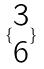Convert formula to latex. <formula><loc_0><loc_0><loc_500><loc_500>\{ \begin{matrix} 3 \\ 6 \end{matrix} \}</formula> 